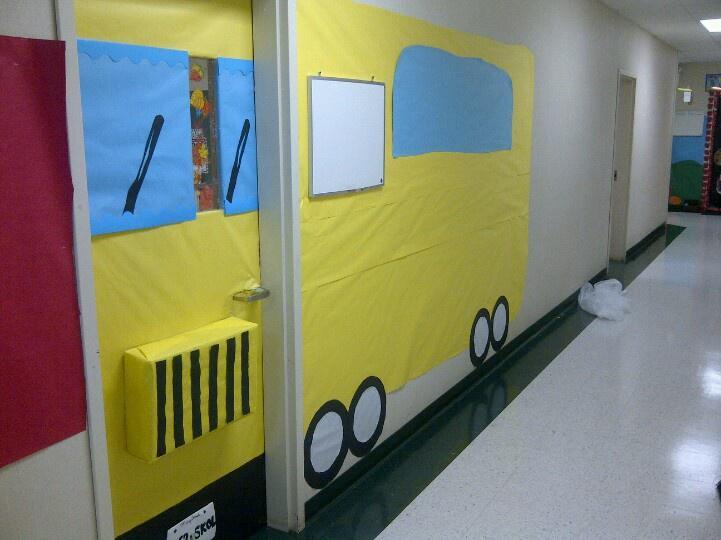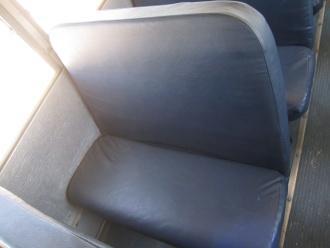The first image is the image on the left, the second image is the image on the right. For the images shown, is this caption "In one of the images only the seat belts are shown." true? Answer yes or no. No. The first image is the image on the left, the second image is the image on the right. Analyze the images presented: Is the assertion "The left image shows an empty gray seat with two seat buckles and straps on the seat back." valid? Answer yes or no. No. 